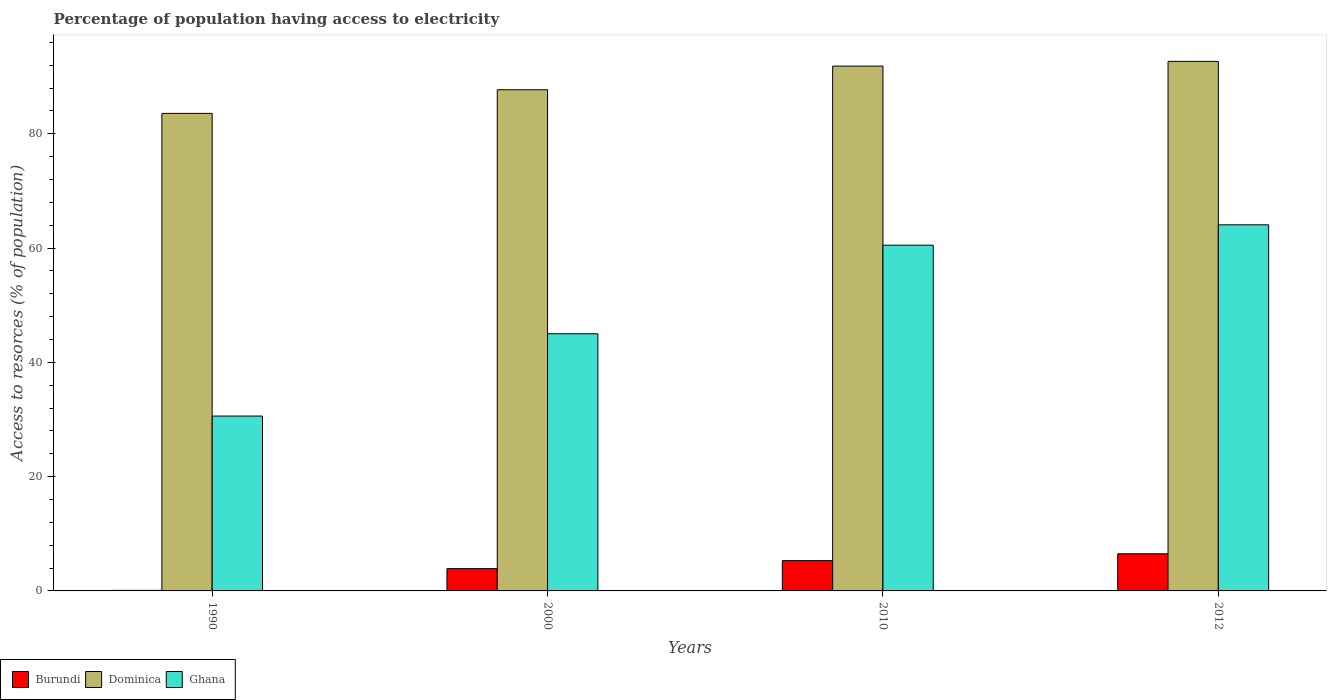How many groups of bars are there?
Your response must be concise. 4. Are the number of bars per tick equal to the number of legend labels?
Give a very brief answer. Yes. How many bars are there on the 3rd tick from the right?
Your response must be concise. 3. What is the percentage of population having access to electricity in Dominica in 1990?
Offer a terse response. 83.56. Across all years, what is the maximum percentage of population having access to electricity in Dominica?
Keep it short and to the point. 92.67. In which year was the percentage of population having access to electricity in Ghana minimum?
Keep it short and to the point. 1990. What is the total percentage of population having access to electricity in Dominica in the graph?
Provide a succinct answer. 355.77. What is the difference between the percentage of population having access to electricity in Ghana in 2000 and that in 2012?
Provide a short and direct response. -19.06. What is the difference between the percentage of population having access to electricity in Burundi in 2000 and the percentage of population having access to electricity in Dominica in 1990?
Your answer should be compact. -79.66. What is the average percentage of population having access to electricity in Dominica per year?
Ensure brevity in your answer.  88.94. In the year 2012, what is the difference between the percentage of population having access to electricity in Dominica and percentage of population having access to electricity in Ghana?
Ensure brevity in your answer.  28.6. In how many years, is the percentage of population having access to electricity in Ghana greater than 64 %?
Provide a short and direct response. 1. What is the ratio of the percentage of population having access to electricity in Ghana in 2000 to that in 2010?
Offer a very short reply. 0.74. Is the difference between the percentage of population having access to electricity in Dominica in 1990 and 2012 greater than the difference between the percentage of population having access to electricity in Ghana in 1990 and 2012?
Keep it short and to the point. Yes. What is the difference between the highest and the second highest percentage of population having access to electricity in Dominica?
Offer a very short reply. 0.83. What is the difference between the highest and the lowest percentage of population having access to electricity in Dominica?
Provide a succinct answer. 9.11. Is the sum of the percentage of population having access to electricity in Ghana in 1990 and 2000 greater than the maximum percentage of population having access to electricity in Dominica across all years?
Give a very brief answer. No. What does the 3rd bar from the left in 2000 represents?
Provide a succinct answer. Ghana. What does the 3rd bar from the right in 2012 represents?
Your response must be concise. Burundi. How many years are there in the graph?
Ensure brevity in your answer.  4. Does the graph contain any zero values?
Provide a succinct answer. No. Where does the legend appear in the graph?
Offer a very short reply. Bottom left. How many legend labels are there?
Provide a short and direct response. 3. How are the legend labels stacked?
Your answer should be very brief. Horizontal. What is the title of the graph?
Provide a succinct answer. Percentage of population having access to electricity. What is the label or title of the X-axis?
Offer a very short reply. Years. What is the label or title of the Y-axis?
Offer a very short reply. Access to resorces (% of population). What is the Access to resorces (% of population) in Dominica in 1990?
Make the answer very short. 83.56. What is the Access to resorces (% of population) of Ghana in 1990?
Offer a very short reply. 30.6. What is the Access to resorces (% of population) in Burundi in 2000?
Your answer should be very brief. 3.9. What is the Access to resorces (% of population) in Dominica in 2000?
Keep it short and to the point. 87.7. What is the Access to resorces (% of population) in Ghana in 2000?
Your response must be concise. 45. What is the Access to resorces (% of population) of Burundi in 2010?
Provide a short and direct response. 5.3. What is the Access to resorces (% of population) of Dominica in 2010?
Offer a very short reply. 91.84. What is the Access to resorces (% of population) of Ghana in 2010?
Offer a terse response. 60.5. What is the Access to resorces (% of population) in Burundi in 2012?
Make the answer very short. 6.5. What is the Access to resorces (% of population) in Dominica in 2012?
Ensure brevity in your answer.  92.67. What is the Access to resorces (% of population) in Ghana in 2012?
Keep it short and to the point. 64.06. Across all years, what is the maximum Access to resorces (% of population) of Burundi?
Your answer should be compact. 6.5. Across all years, what is the maximum Access to resorces (% of population) in Dominica?
Your answer should be compact. 92.67. Across all years, what is the maximum Access to resorces (% of population) in Ghana?
Offer a terse response. 64.06. Across all years, what is the minimum Access to resorces (% of population) in Dominica?
Your response must be concise. 83.56. Across all years, what is the minimum Access to resorces (% of population) of Ghana?
Provide a short and direct response. 30.6. What is the total Access to resorces (% of population) in Dominica in the graph?
Your response must be concise. 355.77. What is the total Access to resorces (% of population) of Ghana in the graph?
Keep it short and to the point. 200.16. What is the difference between the Access to resorces (% of population) in Dominica in 1990 and that in 2000?
Offer a terse response. -4.14. What is the difference between the Access to resorces (% of population) in Ghana in 1990 and that in 2000?
Make the answer very short. -14.4. What is the difference between the Access to resorces (% of population) of Dominica in 1990 and that in 2010?
Your response must be concise. -8.28. What is the difference between the Access to resorces (% of population) of Ghana in 1990 and that in 2010?
Offer a very short reply. -29.9. What is the difference between the Access to resorces (% of population) in Burundi in 1990 and that in 2012?
Make the answer very short. -6.4. What is the difference between the Access to resorces (% of population) of Dominica in 1990 and that in 2012?
Offer a terse response. -9.11. What is the difference between the Access to resorces (% of population) of Ghana in 1990 and that in 2012?
Offer a terse response. -33.46. What is the difference between the Access to resorces (% of population) in Burundi in 2000 and that in 2010?
Your answer should be very brief. -1.4. What is the difference between the Access to resorces (% of population) in Dominica in 2000 and that in 2010?
Ensure brevity in your answer.  -4.14. What is the difference between the Access to resorces (% of population) of Ghana in 2000 and that in 2010?
Ensure brevity in your answer.  -15.5. What is the difference between the Access to resorces (% of population) of Dominica in 2000 and that in 2012?
Provide a short and direct response. -4.97. What is the difference between the Access to resorces (% of population) of Ghana in 2000 and that in 2012?
Your answer should be compact. -19.06. What is the difference between the Access to resorces (% of population) of Dominica in 2010 and that in 2012?
Provide a succinct answer. -0.83. What is the difference between the Access to resorces (% of population) in Ghana in 2010 and that in 2012?
Offer a terse response. -3.56. What is the difference between the Access to resorces (% of population) in Burundi in 1990 and the Access to resorces (% of population) in Dominica in 2000?
Your answer should be very brief. -87.6. What is the difference between the Access to resorces (% of population) of Burundi in 1990 and the Access to resorces (% of population) of Ghana in 2000?
Make the answer very short. -44.9. What is the difference between the Access to resorces (% of population) of Dominica in 1990 and the Access to resorces (% of population) of Ghana in 2000?
Your answer should be very brief. 38.56. What is the difference between the Access to resorces (% of population) of Burundi in 1990 and the Access to resorces (% of population) of Dominica in 2010?
Ensure brevity in your answer.  -91.74. What is the difference between the Access to resorces (% of population) of Burundi in 1990 and the Access to resorces (% of population) of Ghana in 2010?
Give a very brief answer. -60.4. What is the difference between the Access to resorces (% of population) of Dominica in 1990 and the Access to resorces (% of population) of Ghana in 2010?
Keep it short and to the point. 23.06. What is the difference between the Access to resorces (% of population) in Burundi in 1990 and the Access to resorces (% of population) in Dominica in 2012?
Give a very brief answer. -92.57. What is the difference between the Access to resorces (% of population) of Burundi in 1990 and the Access to resorces (% of population) of Ghana in 2012?
Provide a succinct answer. -63.96. What is the difference between the Access to resorces (% of population) of Dominica in 1990 and the Access to resorces (% of population) of Ghana in 2012?
Your response must be concise. 19.5. What is the difference between the Access to resorces (% of population) in Burundi in 2000 and the Access to resorces (% of population) in Dominica in 2010?
Give a very brief answer. -87.94. What is the difference between the Access to resorces (% of population) in Burundi in 2000 and the Access to resorces (% of population) in Ghana in 2010?
Give a very brief answer. -56.6. What is the difference between the Access to resorces (% of population) of Dominica in 2000 and the Access to resorces (% of population) of Ghana in 2010?
Your answer should be very brief. 27.2. What is the difference between the Access to resorces (% of population) of Burundi in 2000 and the Access to resorces (% of population) of Dominica in 2012?
Your answer should be compact. -88.77. What is the difference between the Access to resorces (% of population) of Burundi in 2000 and the Access to resorces (% of population) of Ghana in 2012?
Make the answer very short. -60.16. What is the difference between the Access to resorces (% of population) in Dominica in 2000 and the Access to resorces (% of population) in Ghana in 2012?
Give a very brief answer. 23.64. What is the difference between the Access to resorces (% of population) in Burundi in 2010 and the Access to resorces (% of population) in Dominica in 2012?
Your response must be concise. -87.37. What is the difference between the Access to resorces (% of population) in Burundi in 2010 and the Access to resorces (% of population) in Ghana in 2012?
Offer a very short reply. -58.76. What is the difference between the Access to resorces (% of population) in Dominica in 2010 and the Access to resorces (% of population) in Ghana in 2012?
Make the answer very short. 27.78. What is the average Access to resorces (% of population) of Burundi per year?
Make the answer very short. 3.95. What is the average Access to resorces (% of population) of Dominica per year?
Your answer should be compact. 88.94. What is the average Access to resorces (% of population) of Ghana per year?
Keep it short and to the point. 50.04. In the year 1990, what is the difference between the Access to resorces (% of population) of Burundi and Access to resorces (% of population) of Dominica?
Provide a succinct answer. -83.46. In the year 1990, what is the difference between the Access to resorces (% of population) of Burundi and Access to resorces (% of population) of Ghana?
Ensure brevity in your answer.  -30.5. In the year 1990, what is the difference between the Access to resorces (% of population) in Dominica and Access to resorces (% of population) in Ghana?
Provide a succinct answer. 52.96. In the year 2000, what is the difference between the Access to resorces (% of population) in Burundi and Access to resorces (% of population) in Dominica?
Offer a terse response. -83.8. In the year 2000, what is the difference between the Access to resorces (% of population) in Burundi and Access to resorces (% of population) in Ghana?
Provide a succinct answer. -41.1. In the year 2000, what is the difference between the Access to resorces (% of population) of Dominica and Access to resorces (% of population) of Ghana?
Make the answer very short. 42.7. In the year 2010, what is the difference between the Access to resorces (% of population) of Burundi and Access to resorces (% of population) of Dominica?
Offer a very short reply. -86.54. In the year 2010, what is the difference between the Access to resorces (% of population) in Burundi and Access to resorces (% of population) in Ghana?
Offer a terse response. -55.2. In the year 2010, what is the difference between the Access to resorces (% of population) of Dominica and Access to resorces (% of population) of Ghana?
Offer a terse response. 31.34. In the year 2012, what is the difference between the Access to resorces (% of population) in Burundi and Access to resorces (% of population) in Dominica?
Give a very brief answer. -86.17. In the year 2012, what is the difference between the Access to resorces (% of population) in Burundi and Access to resorces (% of population) in Ghana?
Ensure brevity in your answer.  -57.56. In the year 2012, what is the difference between the Access to resorces (% of population) in Dominica and Access to resorces (% of population) in Ghana?
Your answer should be very brief. 28.6. What is the ratio of the Access to resorces (% of population) in Burundi in 1990 to that in 2000?
Offer a terse response. 0.03. What is the ratio of the Access to resorces (% of population) of Dominica in 1990 to that in 2000?
Your response must be concise. 0.95. What is the ratio of the Access to resorces (% of population) in Ghana in 1990 to that in 2000?
Give a very brief answer. 0.68. What is the ratio of the Access to resorces (% of population) of Burundi in 1990 to that in 2010?
Give a very brief answer. 0.02. What is the ratio of the Access to resorces (% of population) in Dominica in 1990 to that in 2010?
Offer a terse response. 0.91. What is the ratio of the Access to resorces (% of population) in Ghana in 1990 to that in 2010?
Make the answer very short. 0.51. What is the ratio of the Access to resorces (% of population) in Burundi in 1990 to that in 2012?
Keep it short and to the point. 0.02. What is the ratio of the Access to resorces (% of population) in Dominica in 1990 to that in 2012?
Keep it short and to the point. 0.9. What is the ratio of the Access to resorces (% of population) in Ghana in 1990 to that in 2012?
Provide a short and direct response. 0.48. What is the ratio of the Access to resorces (% of population) in Burundi in 2000 to that in 2010?
Offer a terse response. 0.74. What is the ratio of the Access to resorces (% of population) of Dominica in 2000 to that in 2010?
Provide a short and direct response. 0.95. What is the ratio of the Access to resorces (% of population) in Ghana in 2000 to that in 2010?
Ensure brevity in your answer.  0.74. What is the ratio of the Access to resorces (% of population) of Burundi in 2000 to that in 2012?
Your response must be concise. 0.6. What is the ratio of the Access to resorces (% of population) of Dominica in 2000 to that in 2012?
Make the answer very short. 0.95. What is the ratio of the Access to resorces (% of population) of Ghana in 2000 to that in 2012?
Offer a terse response. 0.7. What is the ratio of the Access to resorces (% of population) in Burundi in 2010 to that in 2012?
Your response must be concise. 0.82. What is the ratio of the Access to resorces (% of population) of Dominica in 2010 to that in 2012?
Ensure brevity in your answer.  0.99. What is the ratio of the Access to resorces (% of population) in Ghana in 2010 to that in 2012?
Your answer should be compact. 0.94. What is the difference between the highest and the second highest Access to resorces (% of population) in Dominica?
Your answer should be very brief. 0.83. What is the difference between the highest and the second highest Access to resorces (% of population) in Ghana?
Keep it short and to the point. 3.56. What is the difference between the highest and the lowest Access to resorces (% of population) of Dominica?
Make the answer very short. 9.11. What is the difference between the highest and the lowest Access to resorces (% of population) in Ghana?
Make the answer very short. 33.46. 